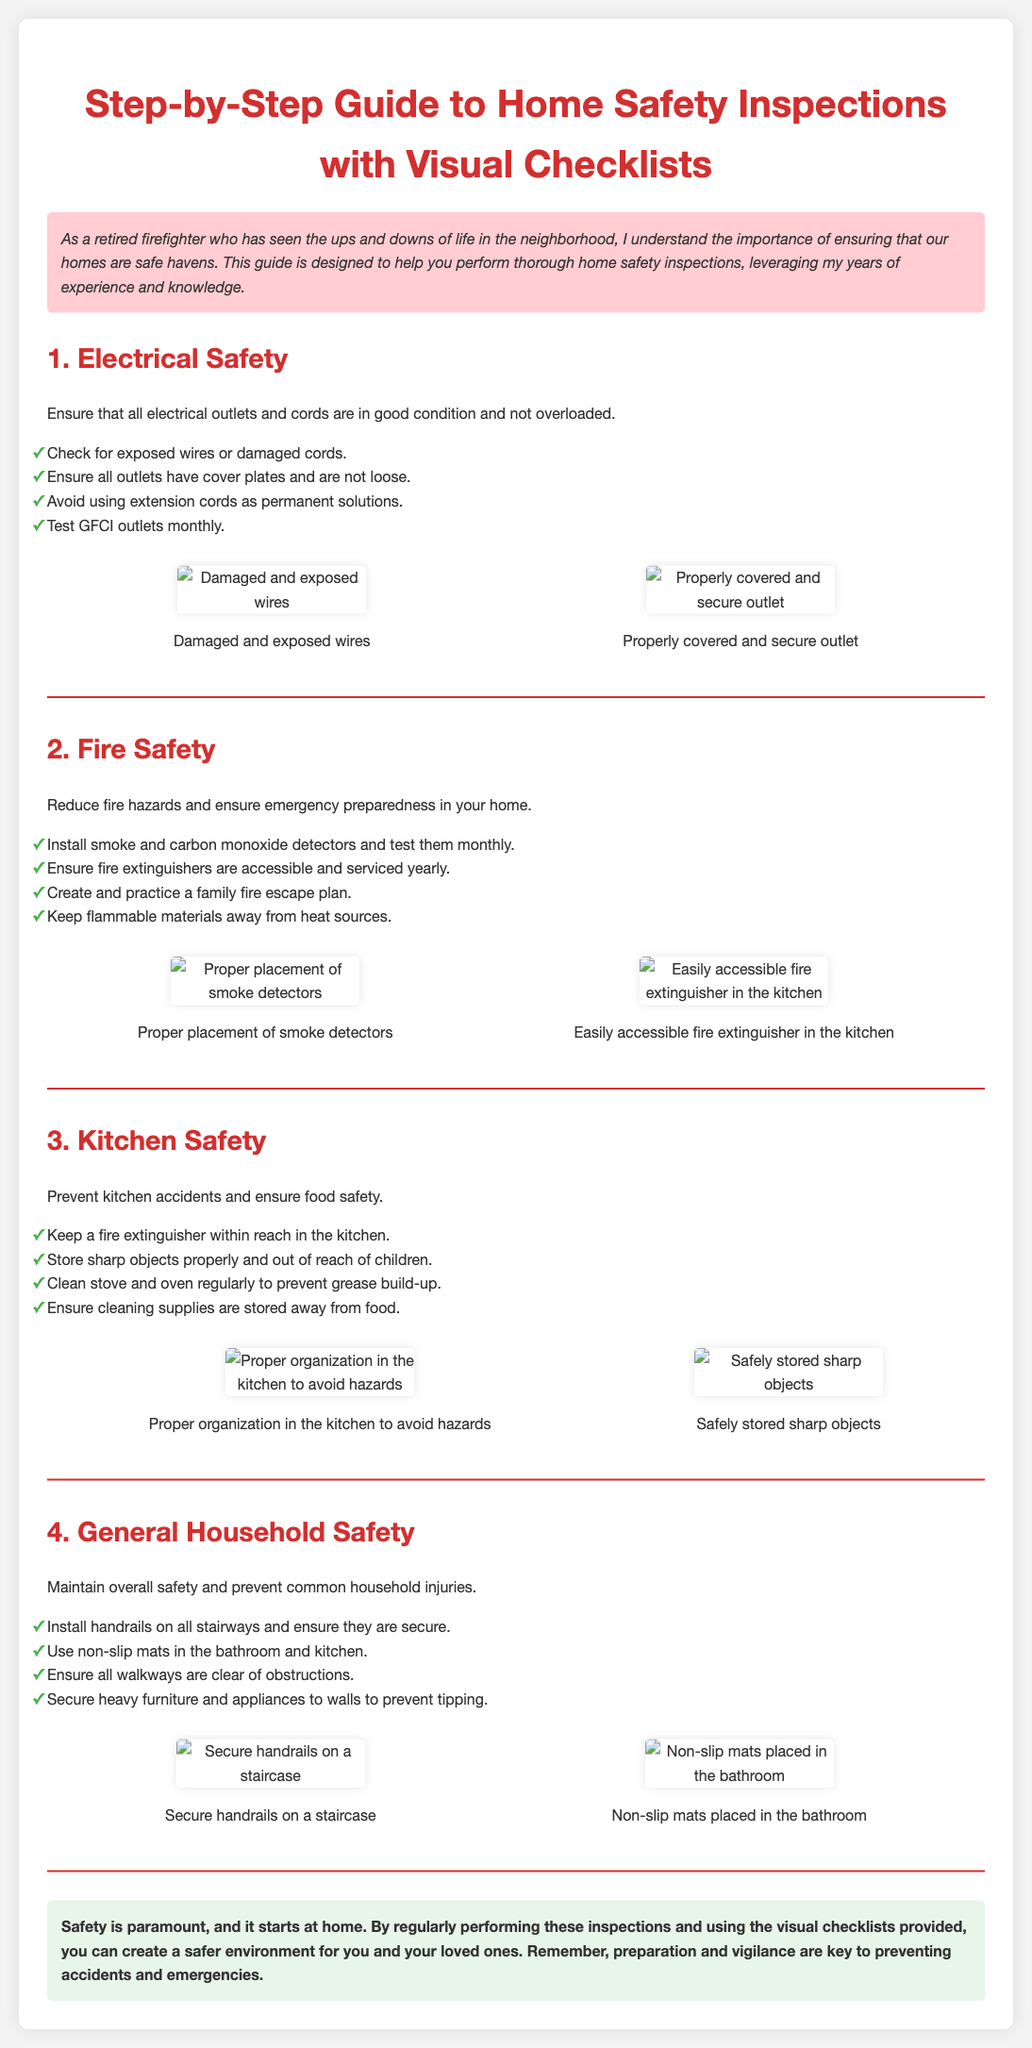What is the primary focus of the guide? The guide primarily focuses on performing home safety inspections to ensure safe living environments.
Answer: Home safety inspections How often should GFCI outlets be tested? The document states that GFCI outlets should be tested monthly for safety.
Answer: Monthly What should be kept away from heat sources in the home? The section on fire safety advises to keep flammable materials away from heat sources.
Answer: Flammable materials Which two safety items should be installed in the home according to the fire safety section? The document mentions installing smoke and carbon monoxide detectors for safety.
Answer: Smoke and carbon monoxide detectors Why is it important to organize the kitchen? Proper organization in the kitchen helps to avoid hazards and prevent accidents, as stated in the kitchen safety section.
Answer: Avoid hazards What type of mats should be used in the bathroom and kitchen? The guide recommends using non-slip mats to enhance safety in those areas.
Answer: Non-slip mats What is a key element of maintaining overall household safety? The guide emphasizes securing heavy furniture and appliances to walls to prevent them from tipping over.
Answer: Securing heavy furniture What are the benefits of practicing a family fire escape plan? Practicing a family fire escape plan improves emergency preparedness and helps ensure everyone's safety.
Answer: Emergency preparedness How should sharp objects be stored to ensure safety? Sharp objects should be stored properly and out of reach of children for safety.
Answer: Out of reach of children 